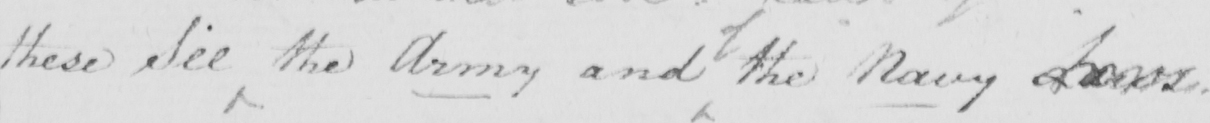What does this handwritten line say? these See the Army and the Navy Laws . 